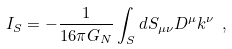Convert formula to latex. <formula><loc_0><loc_0><loc_500><loc_500>I _ { S } = - \frac { 1 } { 1 6 \pi G _ { N } } \int _ { S } d S _ { \mu \nu } D ^ { \mu } k ^ { \nu } \ ,</formula> 